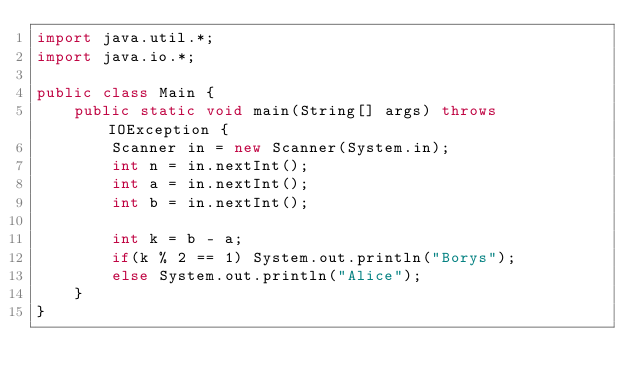<code> <loc_0><loc_0><loc_500><loc_500><_Java_>import java.util.*;
import java.io.*;

public class Main {
	public static void main(String[] args) throws IOException {
		Scanner in = new Scanner(System.in);
		int n = in.nextInt();
		int a = in.nextInt();
		int b = in.nextInt();
		
		int k = b - a;
		if(k % 2 == 1) System.out.println("Borys");
		else System.out.println("Alice");
	}
}</code> 